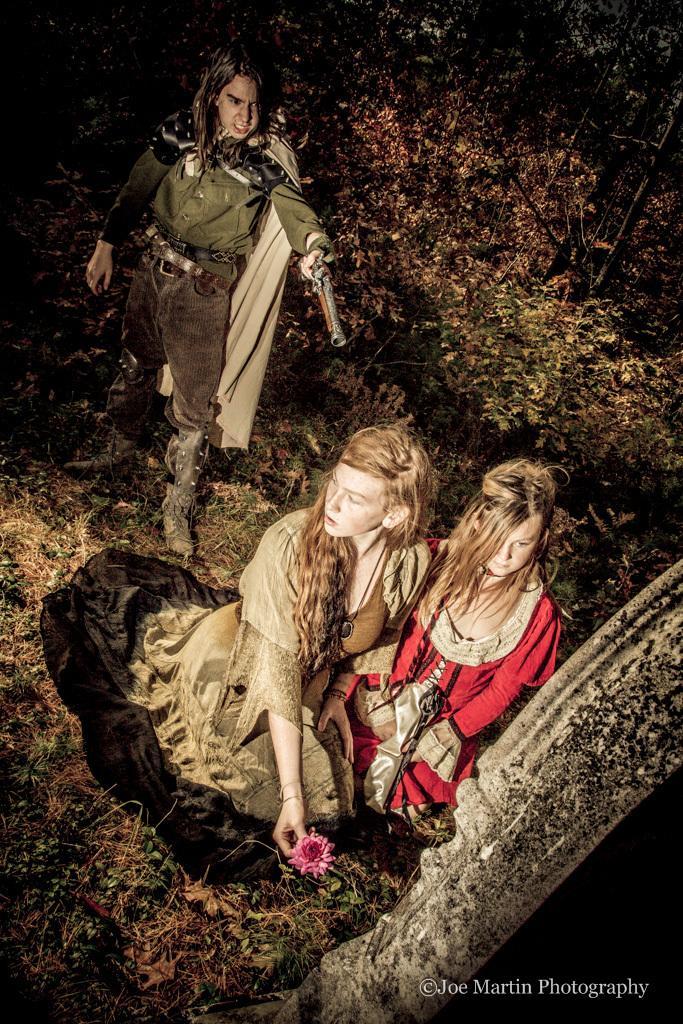Please provide a concise description of this image. In this image we can see three persons, one of them is holding a gun, another person is holding a flower, there are plants, and the grass, also we can see an object which looks like the sculpture. 